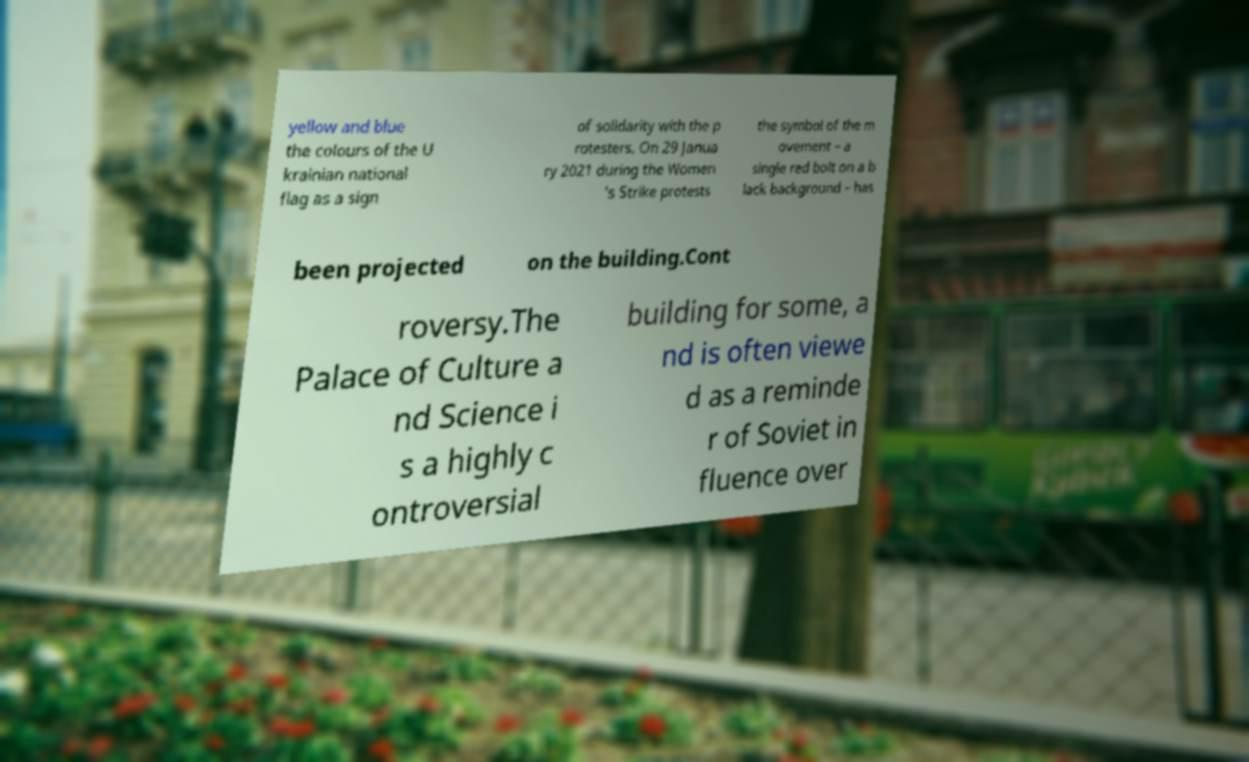For documentation purposes, I need the text within this image transcribed. Could you provide that? yellow and blue the colours of the U krainian national flag as a sign of solidarity with the p rotesters. On 29 Janua ry 2021 during the Women 's Strike protests the symbol of the m ovement – a single red bolt on a b lack background – has been projected on the building.Cont roversy.The Palace of Culture a nd Science i s a highly c ontroversial building for some, a nd is often viewe d as a reminde r of Soviet in fluence over 